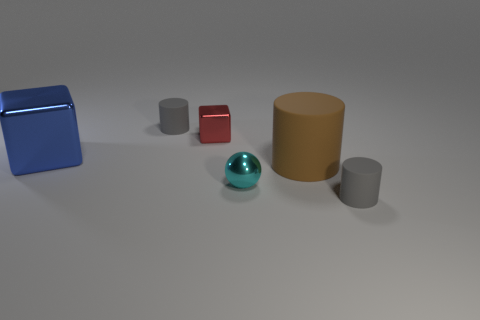How many gray cylinders must be subtracted to get 1 gray cylinders? 1 Subtract all small gray cylinders. How many cylinders are left? 1 Subtract all green spheres. How many gray cylinders are left? 2 Subtract 1 cylinders. How many cylinders are left? 2 Subtract all brown cylinders. How many cylinders are left? 2 Subtract all blue cylinders. Subtract all green cubes. How many cylinders are left? 3 Add 2 blue metal things. How many objects exist? 8 Subtract all large matte cylinders. Subtract all big brown objects. How many objects are left? 4 Add 4 large cylinders. How many large cylinders are left? 5 Add 6 small cubes. How many small cubes exist? 7 